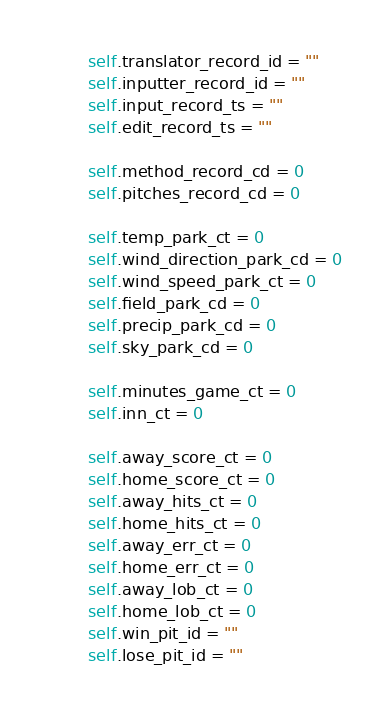Convert code to text. <code><loc_0><loc_0><loc_500><loc_500><_Python_>        self.translator_record_id = ""
        self.inputter_record_id = ""
        self.input_record_ts = ""
        self.edit_record_ts = ""

        self.method_record_cd = 0
        self.pitches_record_cd = 0

        self.temp_park_ct = 0
        self.wind_direction_park_cd = 0
        self.wind_speed_park_ct = 0
        self.field_park_cd = 0
        self.precip_park_cd = 0
        self.sky_park_cd = 0

        self.minutes_game_ct = 0
        self.inn_ct = 0

        self.away_score_ct = 0
        self.home_score_ct = 0
        self.away_hits_ct = 0
        self.home_hits_ct = 0
        self.away_err_ct = 0
        self.home_err_ct = 0
        self.away_lob_ct = 0
        self.home_lob_ct = 0
        self.win_pit_id = ""
        self.lose_pit_id = ""</code> 